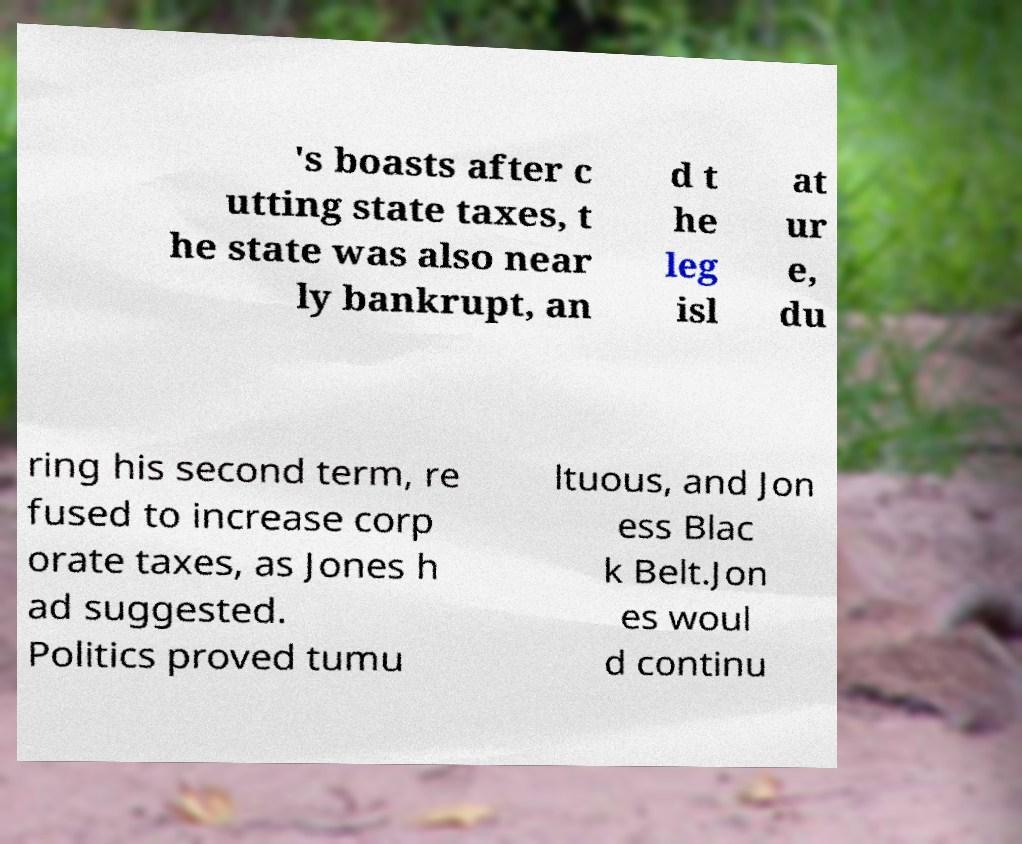There's text embedded in this image that I need extracted. Can you transcribe it verbatim? 's boasts after c utting state taxes, t he state was also near ly bankrupt, an d t he leg isl at ur e, du ring his second term, re fused to increase corp orate taxes, as Jones h ad suggested. Politics proved tumu ltuous, and Jon ess Blac k Belt.Jon es woul d continu 